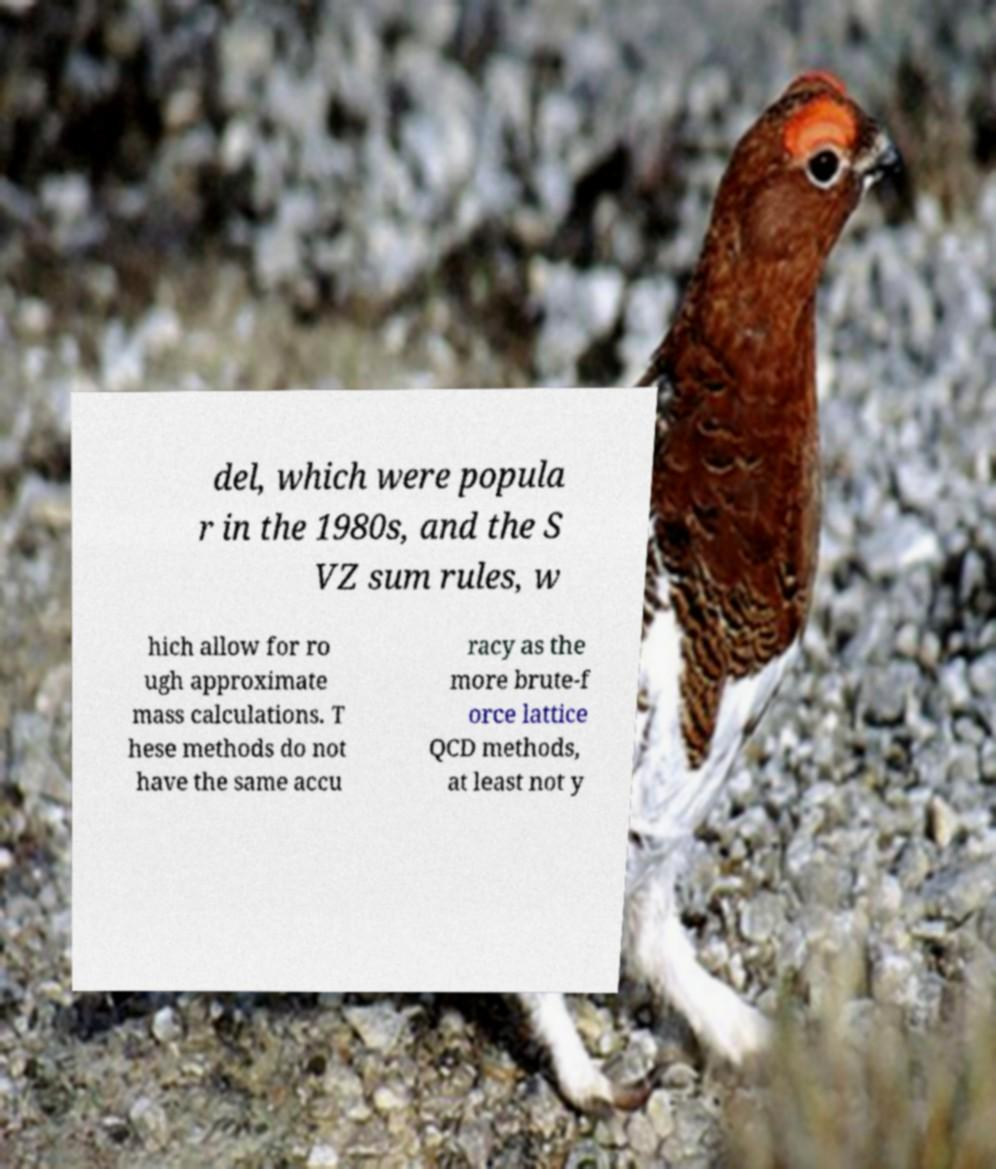There's text embedded in this image that I need extracted. Can you transcribe it verbatim? del, which were popula r in the 1980s, and the S VZ sum rules, w hich allow for ro ugh approximate mass calculations. T hese methods do not have the same accu racy as the more brute-f orce lattice QCD methods, at least not y 